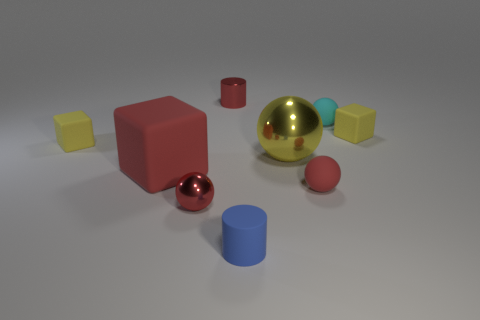Subtract all yellow metal spheres. How many spheres are left? 3 Subtract all red blocks. How many blocks are left? 2 Subtract 1 blocks. How many blocks are left? 2 Add 1 tiny red things. How many objects exist? 10 Subtract all cylinders. How many objects are left? 7 Subtract all gray cylinders. How many gray balls are left? 0 Subtract all small gray shiny balls. Subtract all big rubber things. How many objects are left? 8 Add 3 small blue rubber cylinders. How many small blue rubber cylinders are left? 4 Add 5 big balls. How many big balls exist? 6 Subtract 0 brown spheres. How many objects are left? 9 